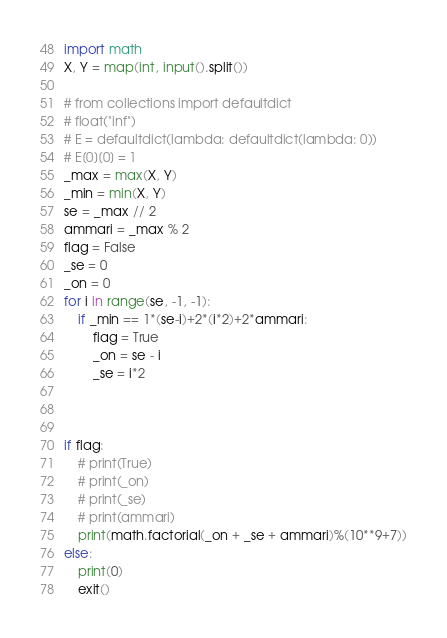<code> <loc_0><loc_0><loc_500><loc_500><_Python_>import math
X, Y = map(int, input().split())

# from collections import defaultdict
# float("inf")
# E = defaultdict(lambda: defaultdict(lambda: 0))
# E[0][0] = 1
_max = max(X, Y)
_min = min(X, Y)
se = _max // 2
ammari = _max % 2
flag = False
_se = 0
_on = 0
for i in range(se, -1, -1):
    if _min == 1*(se-i)+2*(i*2)+2*ammari:
        flag = True
        _on = se - i
        _se = i*2



if flag:
    # print(True)
    # print(_on)
    # print(_se)
    # print(ammari)
    print(math.factorial(_on + _se + ammari)%(10**9+7))
else:
    print(0)
    exit()</code> 